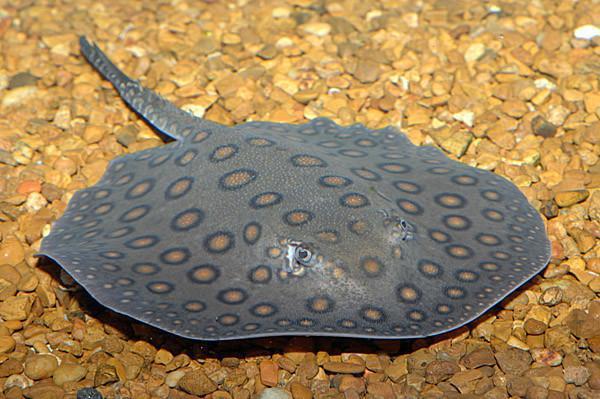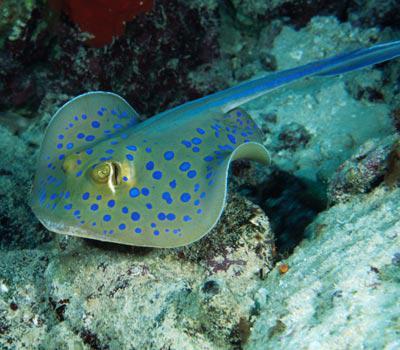The first image is the image on the left, the second image is the image on the right. Given the left and right images, does the statement "All stingrays shown have distinctive colorful dot patterns." hold true? Answer yes or no. Yes. 